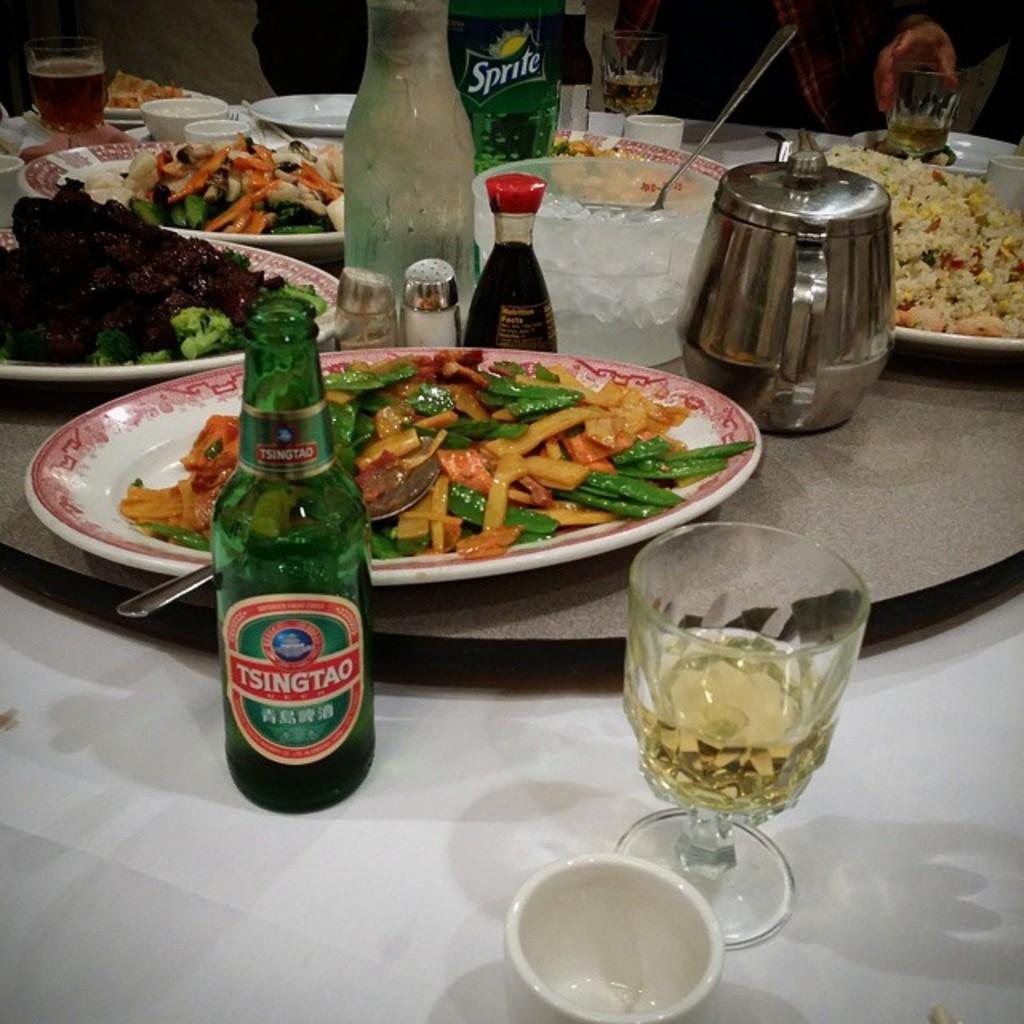What is the main piece of furniture in the image? There is a table in the image. What is placed on the table? There is a plate, a bottle, crunches, strawberries, a wine bottle, a spoon, a jar, and a cool drink on the table. Can you describe the food items on the table? There are crunches and strawberries on the table, which are food items. What type of drink is on the table? There is a cool drink on the table. What channel is the letter being sent through in the image? There is no letter or channel present in the image. What type of base is supporting the table in the image? The image does not show the base of the table, so it cannot be determined from the image. 